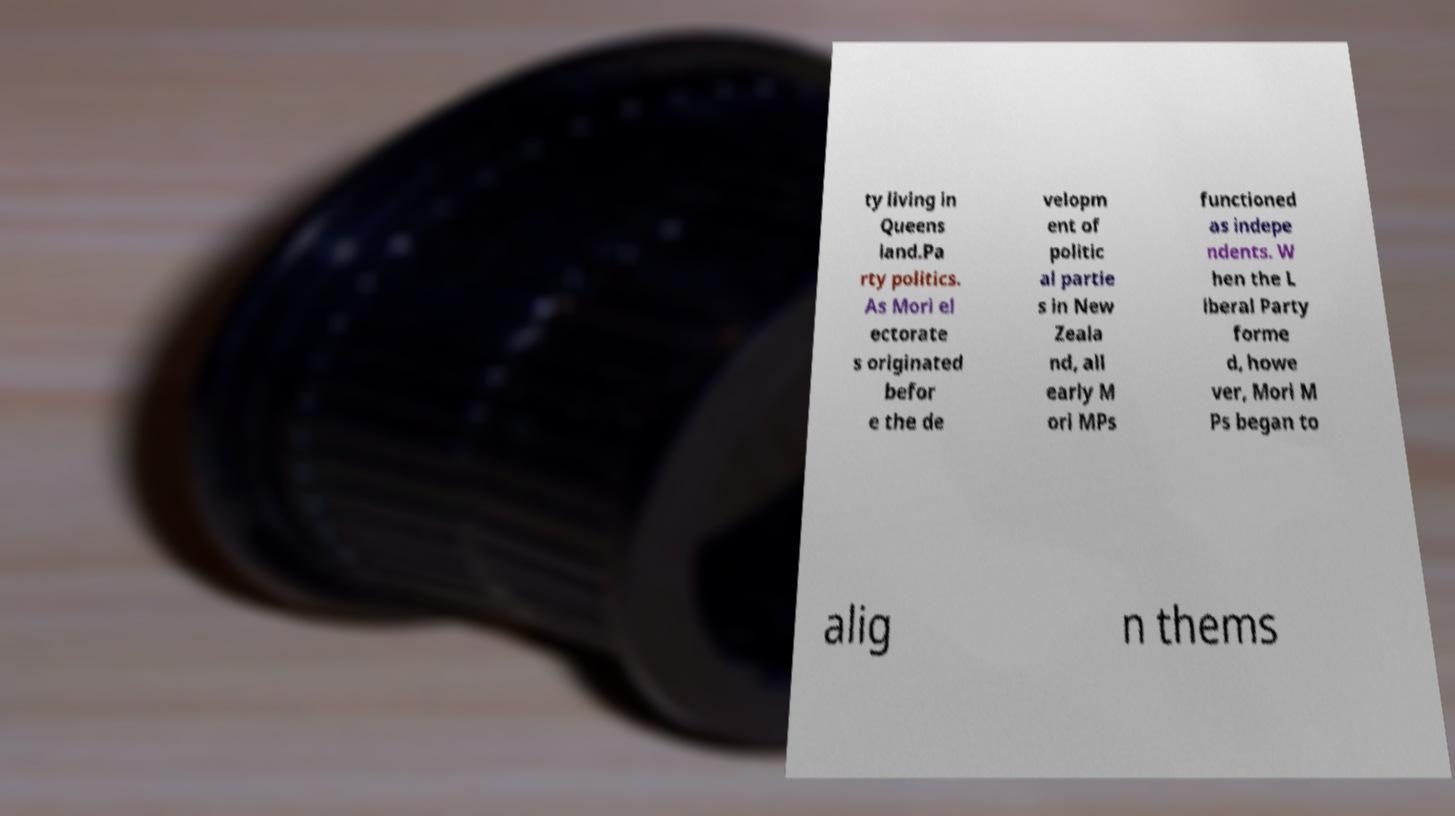What messages or text are displayed in this image? I need them in a readable, typed format. ty living in Queens land.Pa rty politics. As Mori el ectorate s originated befor e the de velopm ent of politic al partie s in New Zeala nd, all early M ori MPs functioned as indepe ndents. W hen the L iberal Party forme d, howe ver, Mori M Ps began to alig n thems 